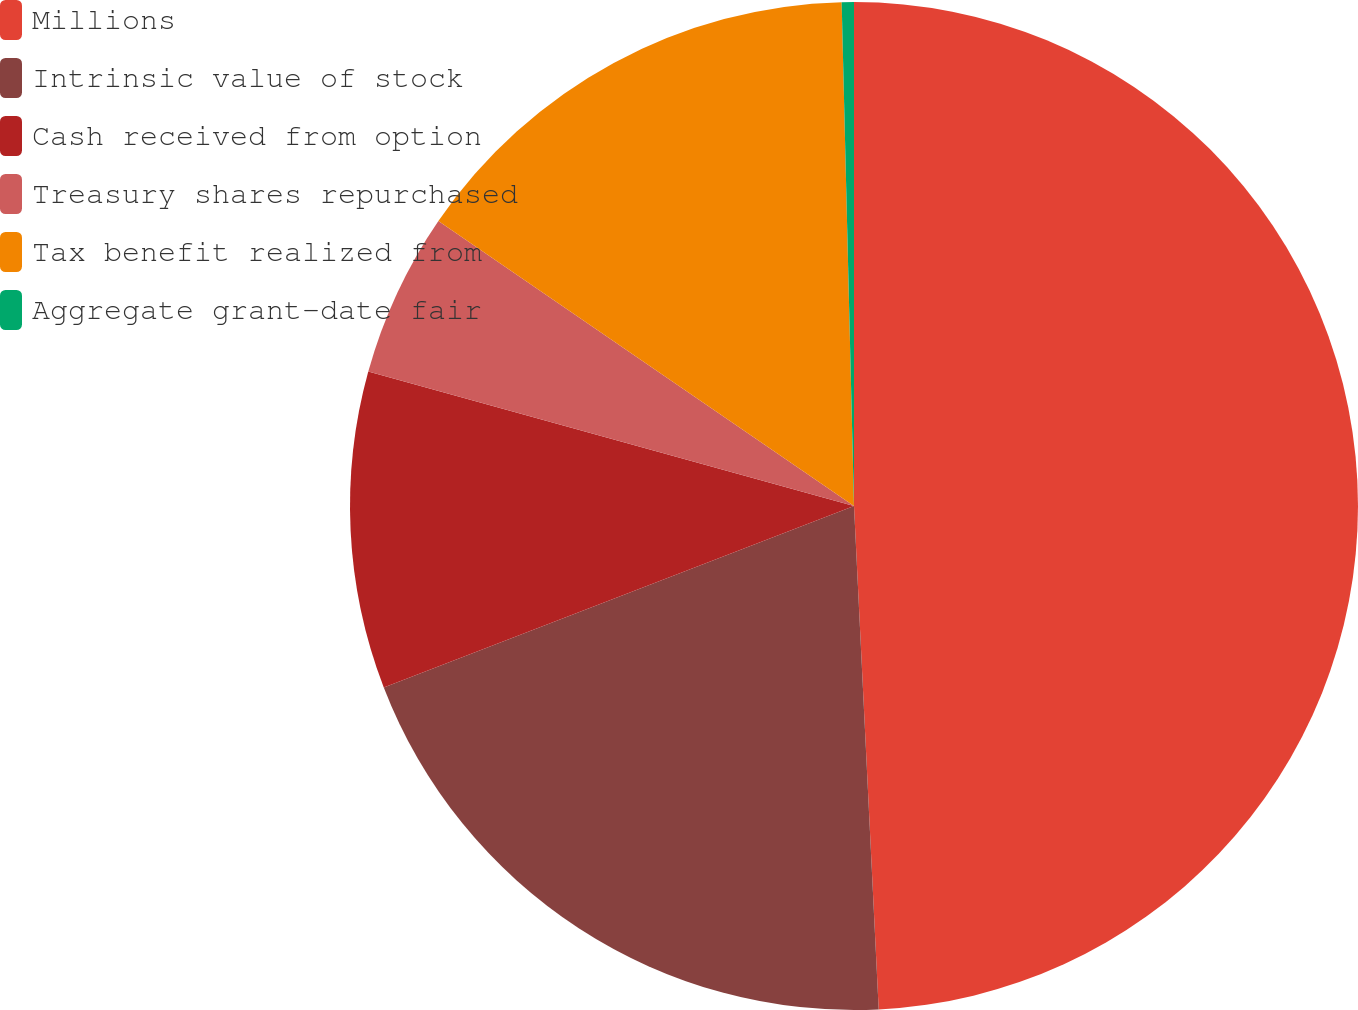Convert chart to OTSL. <chart><loc_0><loc_0><loc_500><loc_500><pie_chart><fcel>Millions<fcel>Intrinsic value of stock<fcel>Cash received from option<fcel>Treasury shares repurchased<fcel>Tax benefit realized from<fcel>Aggregate grant-date fair<nl><fcel>49.22%<fcel>19.92%<fcel>10.16%<fcel>5.27%<fcel>15.04%<fcel>0.39%<nl></chart> 